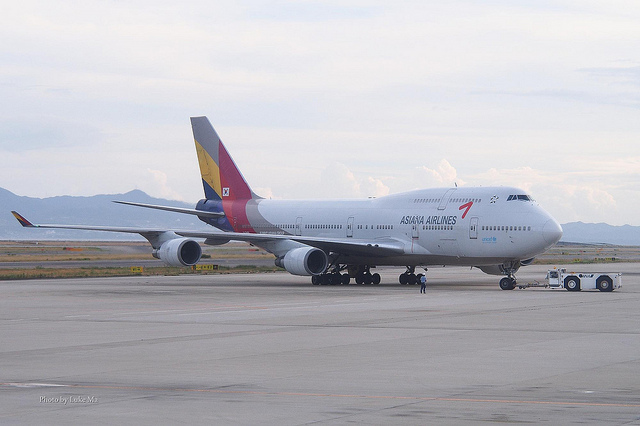<image>Where is the train going? There is no train in the image. It is ambiguous where the train is going. Where is the train going? I don't know where the train is going. It is possible that there is no train or the train is going nowhere. 